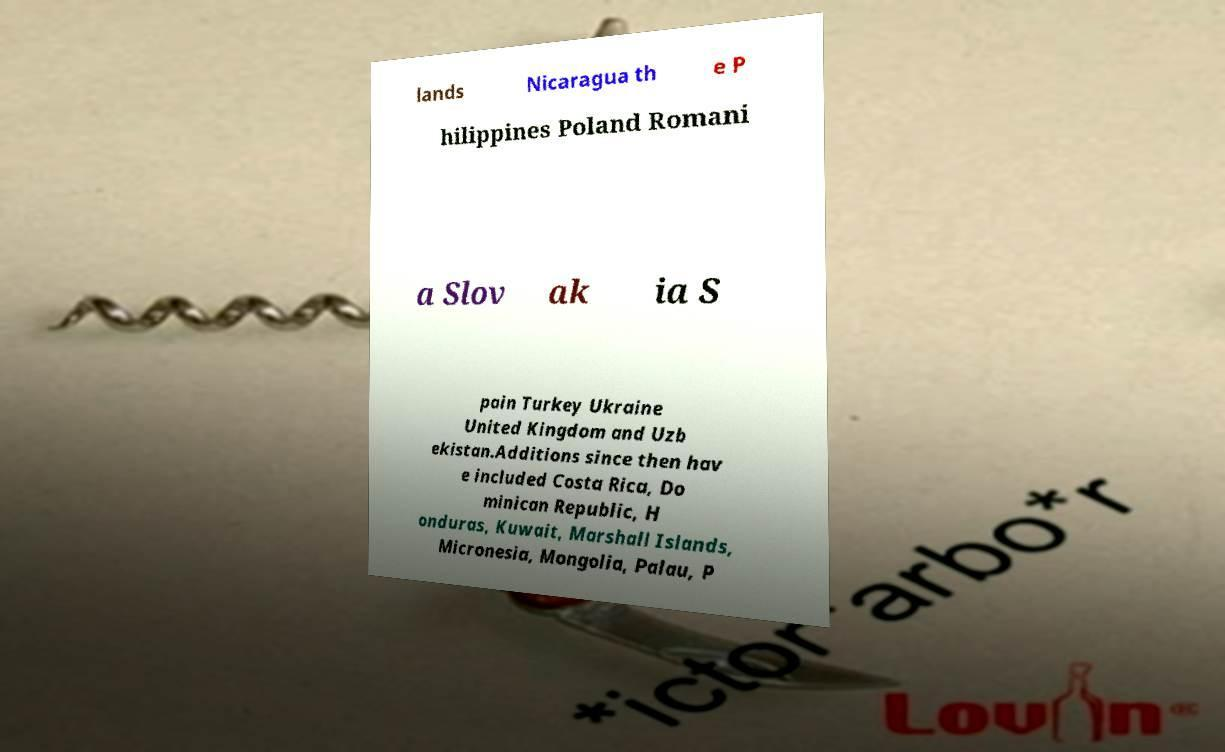There's text embedded in this image that I need extracted. Can you transcribe it verbatim? lands Nicaragua th e P hilippines Poland Romani a Slov ak ia S pain Turkey Ukraine United Kingdom and Uzb ekistan.Additions since then hav e included Costa Rica, Do minican Republic, H onduras, Kuwait, Marshall Islands, Micronesia, Mongolia, Palau, P 